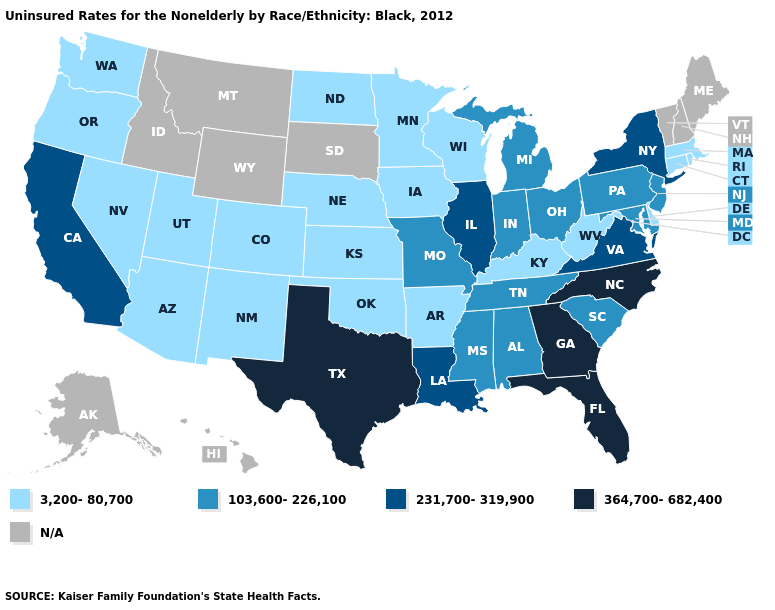What is the lowest value in states that border Oregon?
Be succinct. 3,200-80,700. Name the states that have a value in the range 103,600-226,100?
Concise answer only. Alabama, Indiana, Maryland, Michigan, Mississippi, Missouri, New Jersey, Ohio, Pennsylvania, South Carolina, Tennessee. What is the lowest value in the Northeast?
Concise answer only. 3,200-80,700. What is the value of Mississippi?
Give a very brief answer. 103,600-226,100. Name the states that have a value in the range 103,600-226,100?
Concise answer only. Alabama, Indiana, Maryland, Michigan, Mississippi, Missouri, New Jersey, Ohio, Pennsylvania, South Carolina, Tennessee. Name the states that have a value in the range 231,700-319,900?
Be succinct. California, Illinois, Louisiana, New York, Virginia. What is the value of Delaware?
Answer briefly. 3,200-80,700. Does California have the highest value in the West?
Concise answer only. Yes. What is the value of Oklahoma?
Answer briefly. 3,200-80,700. Which states have the highest value in the USA?
Write a very short answer. Florida, Georgia, North Carolina, Texas. How many symbols are there in the legend?
Be succinct. 5. Name the states that have a value in the range 364,700-682,400?
Write a very short answer. Florida, Georgia, North Carolina, Texas. Does Mississippi have the lowest value in the USA?
Answer briefly. No. Does Massachusetts have the lowest value in the USA?
Give a very brief answer. Yes. 